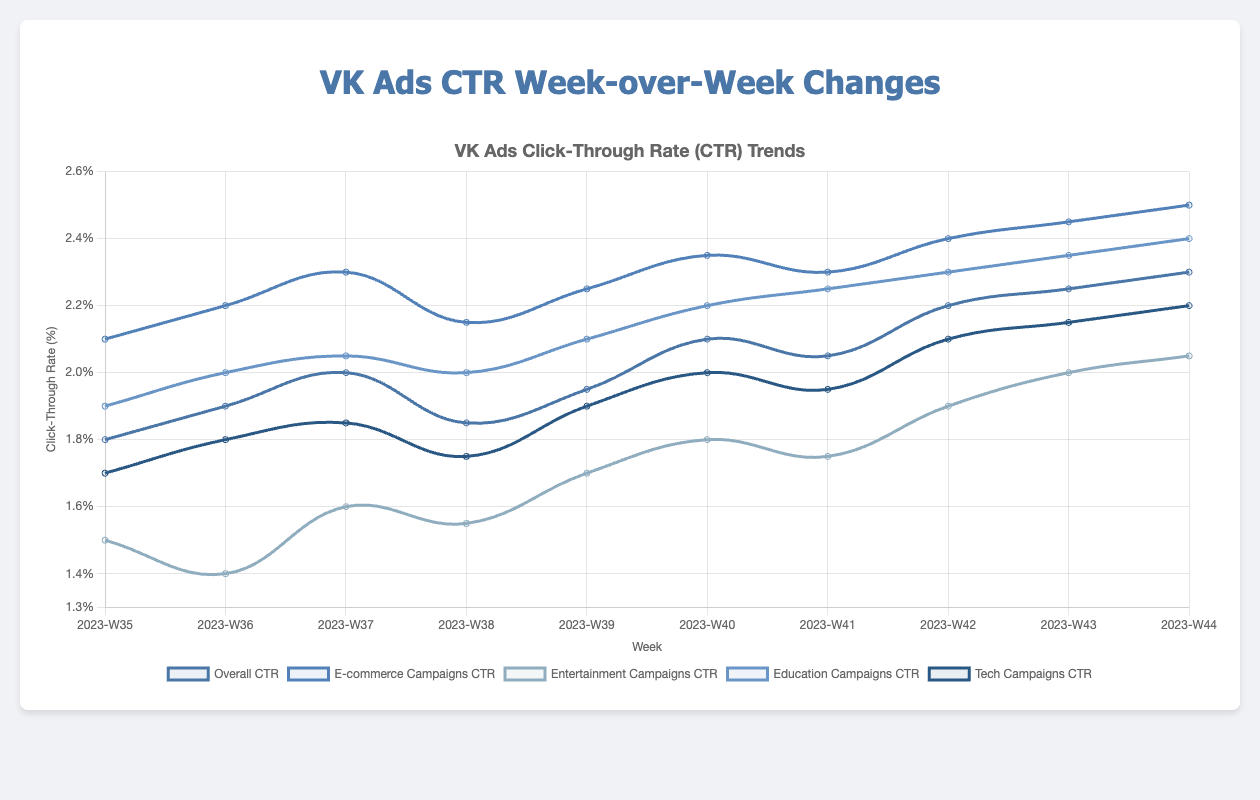What is the overall trend in the CTR for VK Ads from week 35 to week 44? The overall CTR for VK Ads shows an increasing trend from 1.8% in week 35 to 2.3% in week 44, with some fluctuations in between. Specifically, the CTR rises steadily most weeks and peaks in week 44.
Answer: Increasing How does the CTR for Entertainment Campaigns compare to the CTR for E-commerce Campaigns in week 40? In week 40, the CTR for Entertainment Campaigns is 1.8%, while the CTR for E-commerce Campaigns is 2.35%. We can see that the E-commerce Campaigns have a higher CTR than Entertainment Campaigns by 0.55%.
Answer: E-commerce Campaigns have a higher CTR During which week does the Education Campaigns CTR first surpass the Tech Campaigns CTR, and by how much does it surpass? The Education Campaigns CTR first surpasses the Tech Campaigns CTR in week 36, where it is 2.0% compared to the Tech Campaigns CTR of 1.8%. It surpasses by 0.2%.
Answer: Week 36, 0.2% What is the range of values for the Tech Campaigns CTR from week 35 to week 39? The range is calculated by finding the difference between the maximum and minimum values of the Tech Campaigns CTR from week 35 to week 39. The maximum is 1.9% (week 39), and the minimum is 1.7% (week 35), so the range is 1.9% - 1.7% = 0.2%.
Answer: 0.2 Between weeks 37 and 38, which campaign category shows a decrease in CTR, and by how much? The Tech Campaigns and Education Campaigns show a decrease in CTR between weeks 37 and 38. The Tech Campaigns decrease from 1.85% to 1.75%, a decrease of 0.1%. The Education Campaigns decrease from 2.05% to 2.0%, which is a decrease of 0.05%.
Answer: Tech Campaigns by 0.1% and Education Campaigns by 0.05% What is the average CTR for E-commerce Campaigns across all weeks? To find the average CTR for E-commerce Campaigns, sum all the CTR values and divide by the number of weeks: (2.1% + 2.2% + 2.3% + 2.15% + 2.25% + 2.35% + 2.3% + 2.4% + 2.45% + 2.5%) / 10 = 22.6% / 10 = 2.26%.
Answer: 2.26% Which week shows the largest week-over-week increase in CTR for Overall, and what is the amount of increase? The largest week-over-week increase in CTR for Overall occurs between week 39 and week 40, where the CTR increases from 1.95% to 2.1%, amounting to an increase of 0.15%.
Answer: Week 39 to Week 40, 0.15% What is the median CTR value for Education Campaigns from week 35 to week 44? To find the median, the values must be ordered and the middle value(s) determined. The ordered values for Education Campaigns from week 35 to week 44 are: [1.9%, 2.0%, 2.0%, 2.05%, 2.1%, 2.2%, 2.25%, 2.3%, 2.35%, 2.4%]. The middle values are 2.1% and 2.2%; taking the average of these gives (2.1% + 2.2%) / 2 = 2.15%.
Answer: 2.15% In which weeks do all campaign categories show a CTR of at least 2.0% or higher? Weeks 42, 43, and 44 show CTR values of at least 2.0% or higher for all campaign categories. Reviewing the dataset:
Week 42: all categories have CTR >= 2.0%
Week 43: all categories have CTR >= 2.0%
Week 44: all categories have CTR >= 2.0%
Answer: Weeks 42, 43, 44 